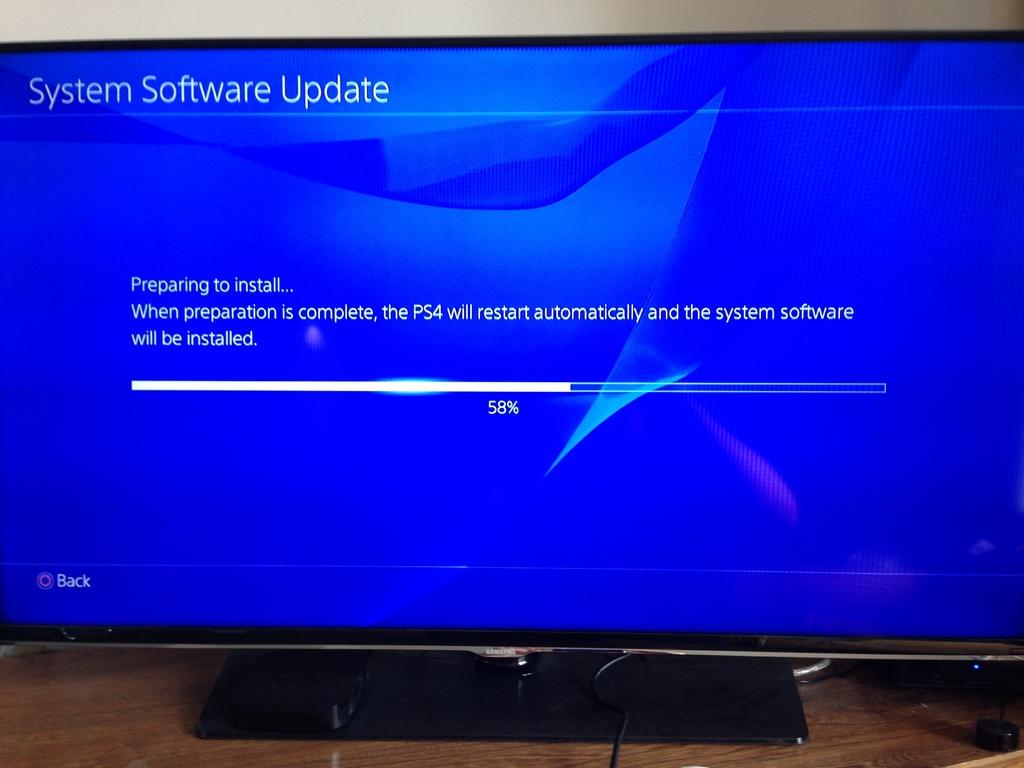What percentage is the install at?
Your answer should be very brief. 58. What console is being updated?
Make the answer very short. Ps4. 